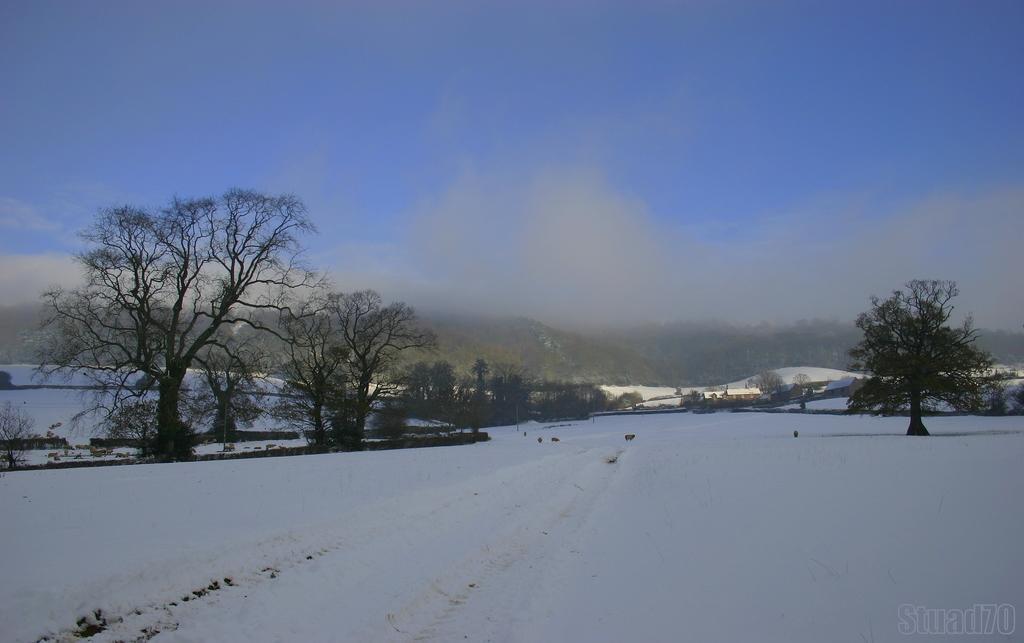In one or two sentences, can you explain what this image depicts? At the bottom we can see snow. In the background there are trees,houses,mountains and clouds in the sky. 